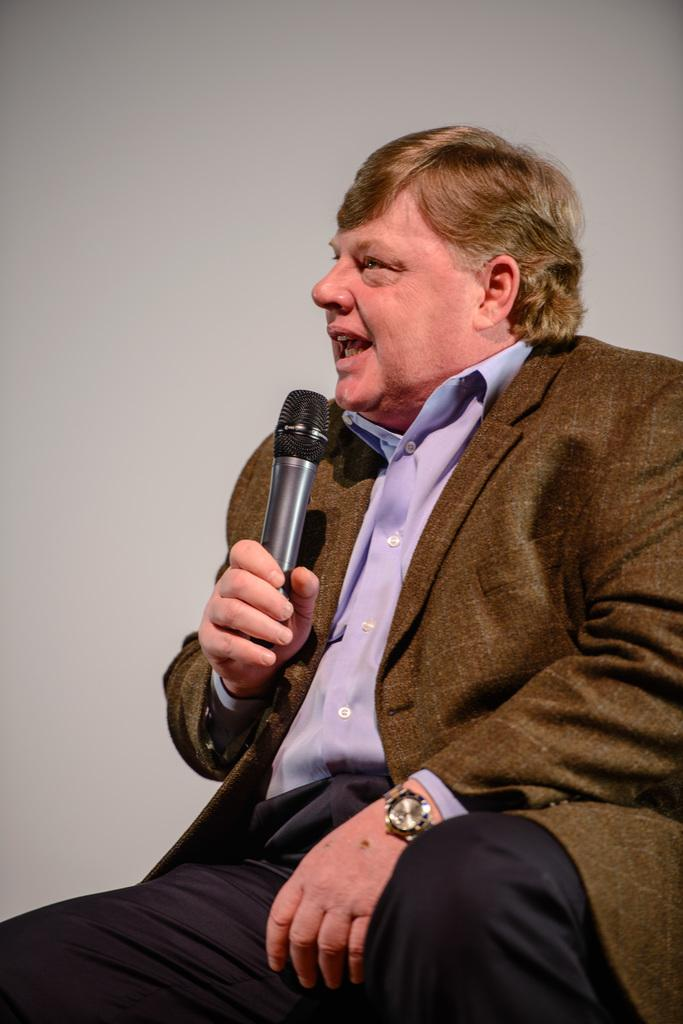Who is present in the image? There is a man in the image. What is the man doing in the image? The man is seated and talking. What object is present in the image that might be related to the man's activity? There is a microphone in the image. What type of yam is the man holding in the image? There is no yam present in the image; the man is holding a microphone. How does the man's nose look in the image? The image does not provide enough detail to describe the man's nose. 